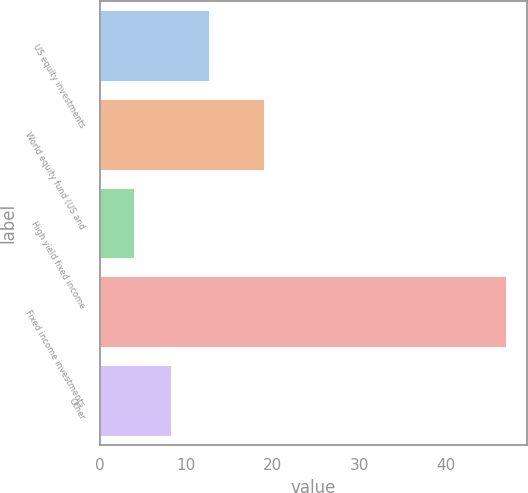Convert chart. <chart><loc_0><loc_0><loc_500><loc_500><bar_chart><fcel>US equity investments<fcel>World equity fund (US and<fcel>High yield fixed income<fcel>Fixed income investments<fcel>Other<nl><fcel>12.6<fcel>19<fcel>4<fcel>47<fcel>8.3<nl></chart> 